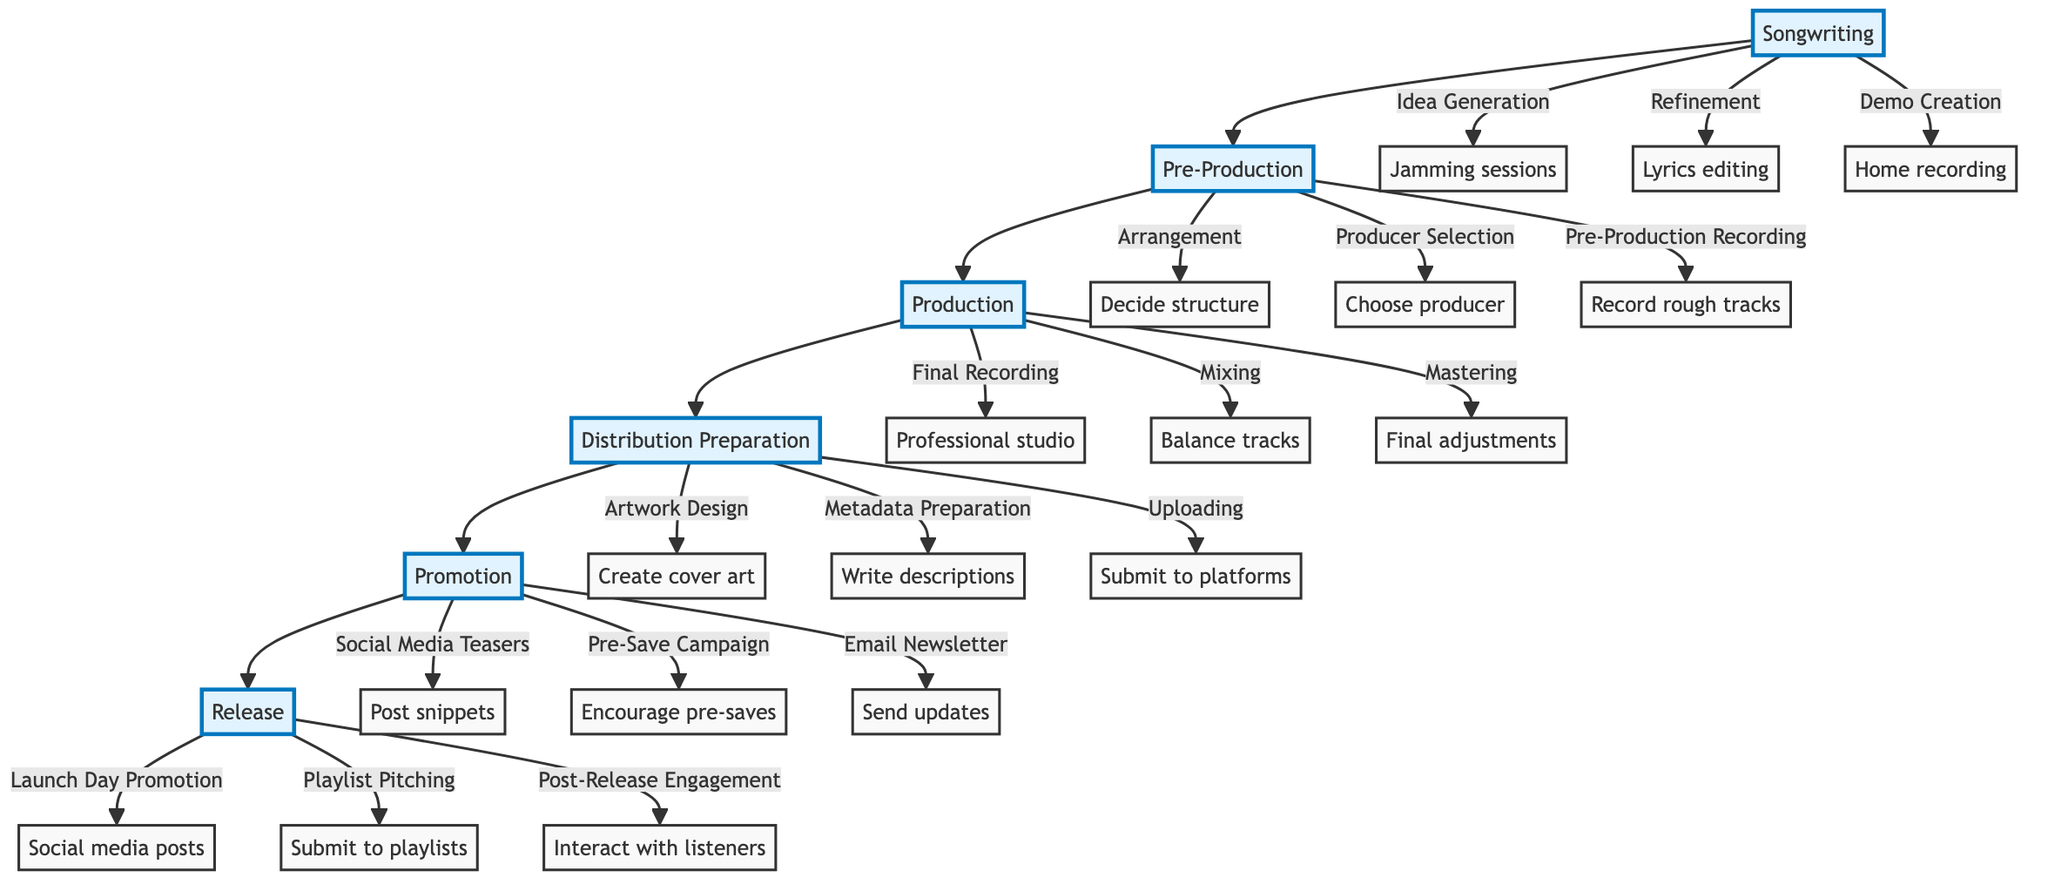What is the first stage of the content creation workflow? The first stage in the workflow is represented by the node labeled "Songwriting." This is the starting point before moving to the next stage, Pre-Production.
Answer: Songwriting How many main stages are there in the workflow? The workflow contains six main stages: Songwriting, Pre-Production, Production, Distribution Preparation, Promotion, and Release. Each of these stages is connected sequentially.
Answer: 6 What is the last step in the distribution preparation phase? The last step in Distribution Preparation is depicted as "Uploading," which follows Artwork Design and Metadata Preparation. This indicates that uploading comes last in this phase.
Answer: Uploading Which stage includes "Mastering"? "Mastering" is located in the Production stage. It follows Final Recording and Mixing, showing its role as the final adjustment process in production.
Answer: Production What two tasks are associated with the Promotion phase? The Promotion phase includes three tasks: Social Media Teasers, Pre-Save Campaign, and Email Newsletter. From these, Social Media Teasers and Pre-Save Campaign can be selected as two tasks associated with this phase.
Answer: Social Media Teasers, Pre-Save Campaign What is the primary purpose of the "Post-Release Engagement" task? "Post-Release Engagement" is included in the last stage of the workflow, Release. Its purpose involves interacting with listeners and sharing reviews after the release has occurred, indicating its function in maintaining listener interest.
Answer: Interacting with listeners How does the "Producer Selection" affect the steps that follow? "Producer Selection" is a critical step in Pre-Production. It directly influences the subsequent step, "Pre-Production Recording," because the choice of producer can determine how rough tracks are recorded. Thus, it sets up essential conditions for the following production efforts.
Answer: Influences recording quality What is the common final step across all major phases of the workflow? Each major phase has a unique last step: However, "Uploading" is the only final step in its respective phase (Distribution Preparation), while other phases end with steps pertinent to their tasks. Thus, each phase's last step is unique and does not share a common terminal node.
Answer: Unique to each phase Which activity is most closely related to the "Final Recording" step? "Final Recording" is closely tied to "Recording vocals and instruments in professional studio," as it illustrates precisely what this step entails. This relationship emphasizes the professional context of this activity within the Production phase.
Answer: Recording vocals and instruments in professional studio 